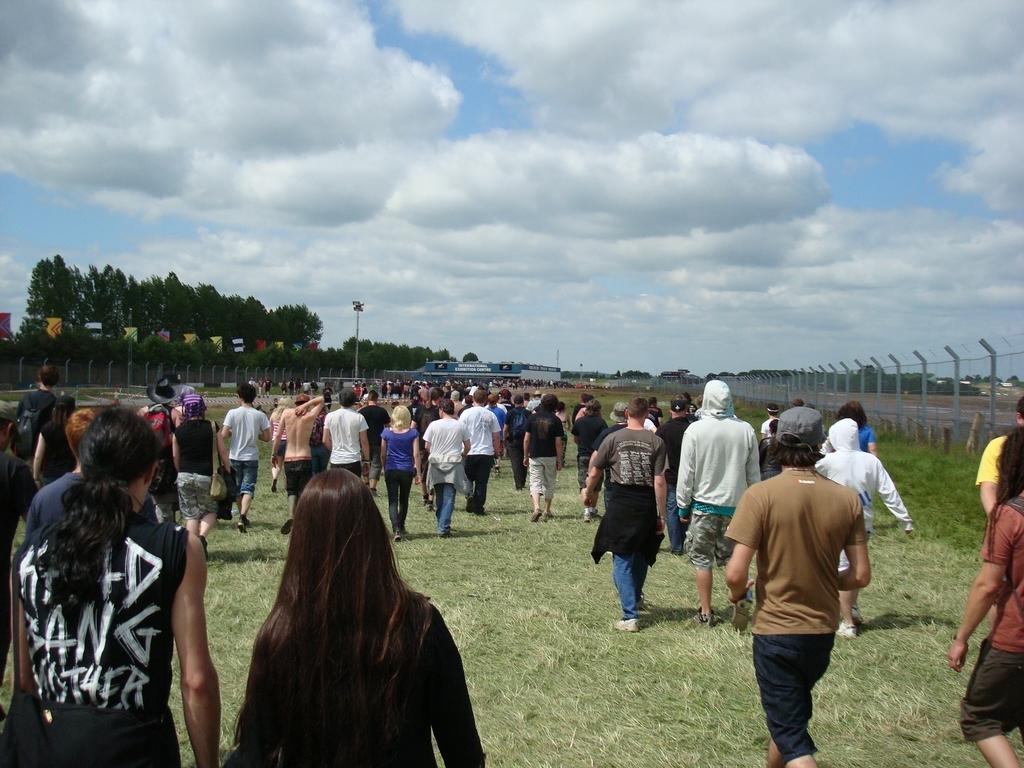How would you summarize this image in a sentence or two? At the bottom of this image, there are persons in different color dresses, walking on the grass on the ground. In the background, there are flags, trees, a fence, poles, there are clouds in the sky and other objects. 